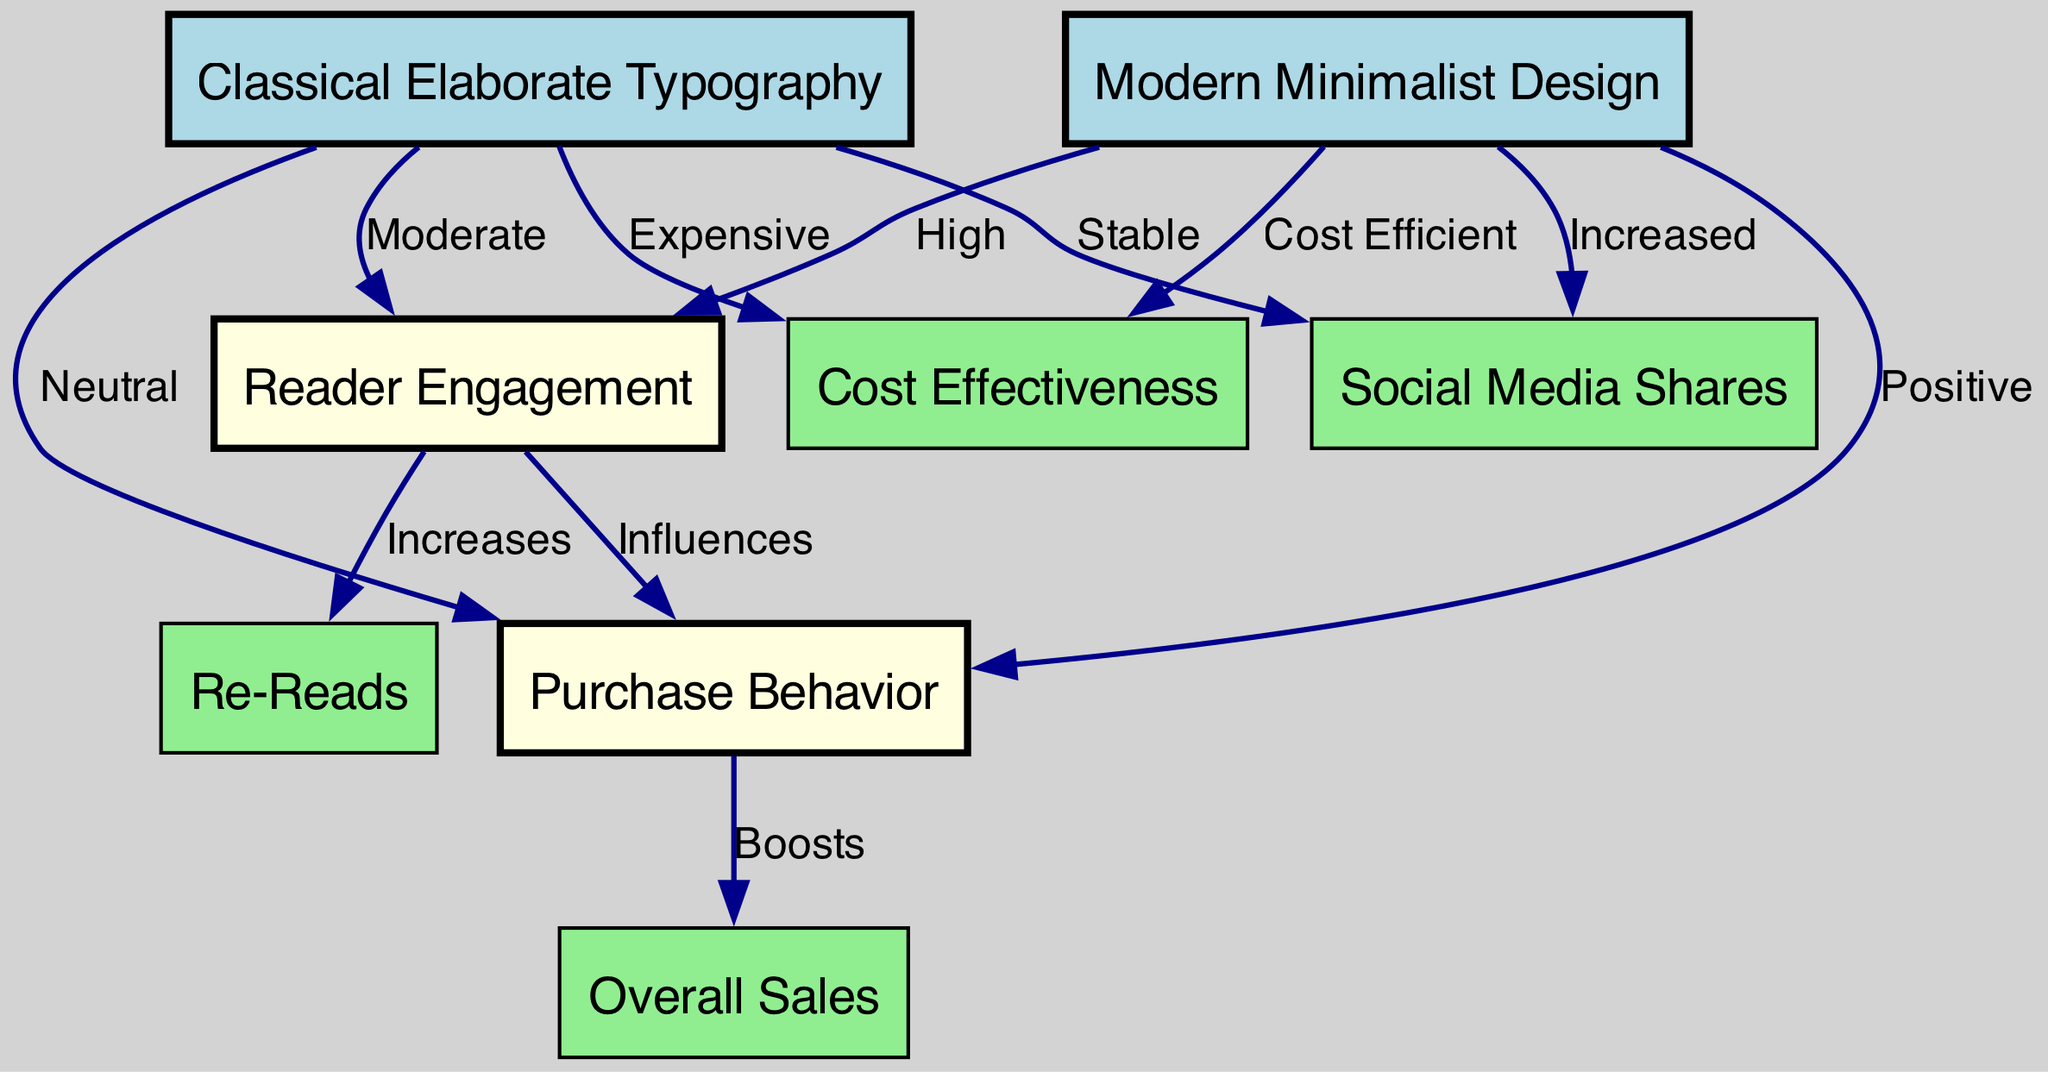What is the engagement level for Modern Minimalist Design? The diagram indicates a "High" level of reader engagement specifically connected to the Modern Minimalist Design node. This can be directly observed along the edge that connects "Modern Minimalist Design" to "Reader Engagement".
Answer: High What node represents overall sales? The node labeled "Overall Sales" represents the total sales associated with book purchases in the context of the diagram, and this can be identified by its specific label in the node list.
Answer: Overall Sales How does Reader Engagement influence Purchase Behavior? The diagram illustrates that "Reader Engagement" influences "Purchase Behavior" with an edge labeled "Influences." This indicates a directional relationship where reader engagement has a direct impact on the behavior of purchases.
Answer: Influences What is the cost effectiveness of Classical Elaborate Typography? The diagram states that Classical Elaborate Typography has an edge pointing to "Cost Effectiveness" labeled "Expensive," indicating that it is not cost-efficient compared to alternatives.
Answer: Expensive How do Social Media Shares differ between the two design types? The diagram shows that Modern Minimalist Design has an edge to "Social Media Shares" labeled "Increased," whereas Classical Elaborate Typography has an edge labeled "Stable." This comparison indicates a significant difference in social media engagement between these two designs.
Answer: Increased and Stable Is overall sales positively impacted by purchase behavior? According to the diagram, there is a directional edge from "Purchase Behavior" to "Overall Sales" labeled "Boosts," clearly indicating that positively trends in purchase behavior lead to increased overall sales.
Answer: Boosts What relationship exists between Reader Engagement and Re-Reads? The diagram illustrates an edge pointing from "Reader Engagement" to "Re-Reads" labeled "Increases," indicating that higher reader engagement typically leads to more re-reads of the books.
Answer: Increases What type of design has moderate reader engagement? The data specifies that Classical Elaborate Typography is associated with "Moderate" reader engagement, as indicated by the corresponding edge connected to the "Reader Engagement" node.
Answer: Moderate How does Modern Minimalist Design fare in terms of cost efficiency? The diagram indicates that Modern Minimalist Design connects to "Cost Effectiveness" with a label stating "Cost Efficient," emphasizing that this design is favorable in cost terms compared to others.
Answer: Cost Efficient 